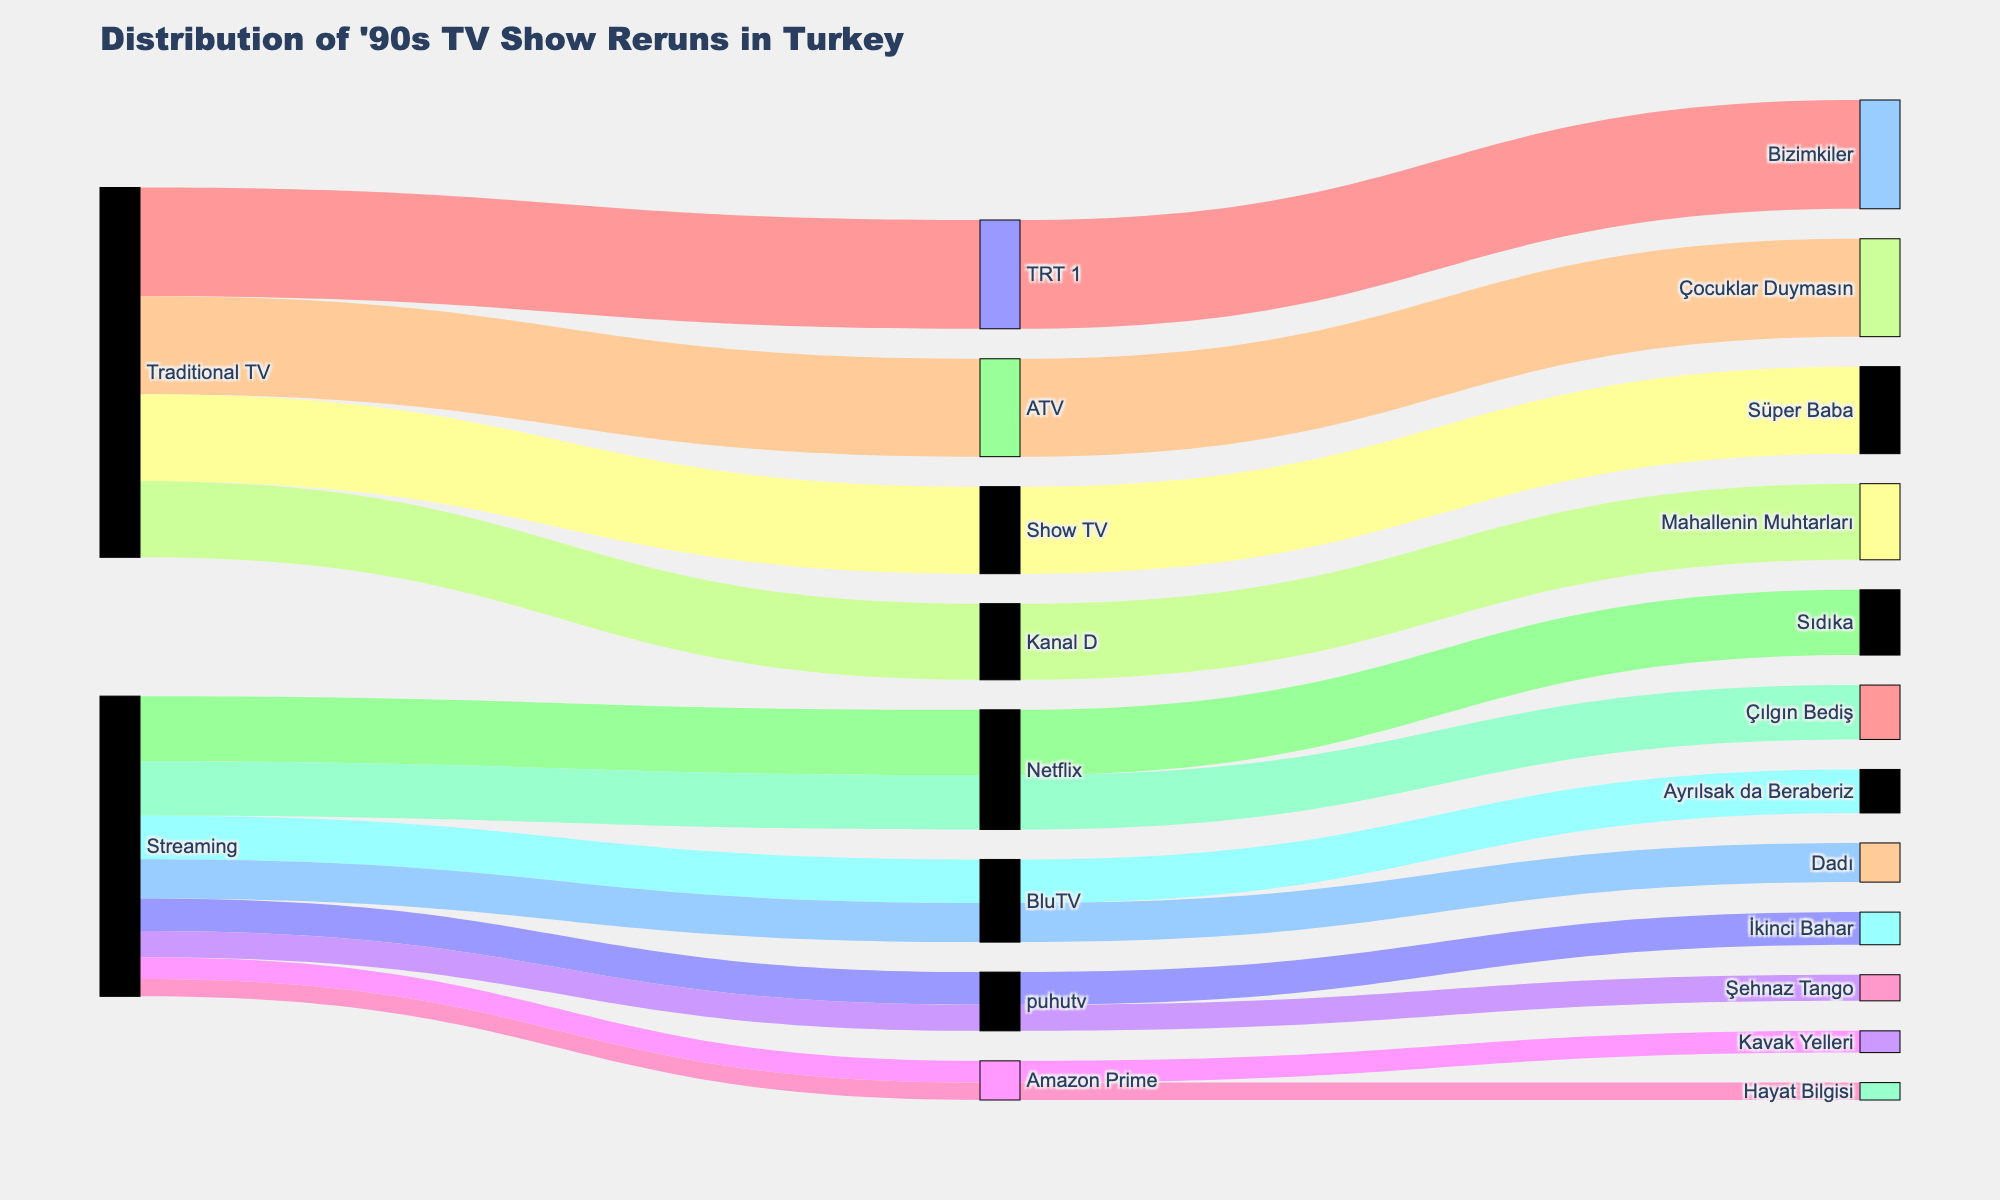What is the title of the figure? The title of the figure usually appears at the top, indicating what the graph represents. Here, it is "Distribution of '90s TV Show Reruns in Turkey".
Answer: Distribution of '90s TV Show Reruns in Turkey How many traditional TV channels are represented in the Sankey diagram? We need to count the number of unique traditional TV channels shown in the figure. They are TRT 1, ATV, Show TV, and Kanal D.
Answer: 4 Which show has the highest number of viewers? By following the width of the flows connected to each show, the one with the widest flow represents the show with the highest viewers. "Bizimkiler" on TRT 1 has the widest flow.
Answer: Bizimkiler How many shows are on streaming platforms compared to traditional TV channels? Sum up the shows under the streaming platforms section and the traditional TV channels section. Streaming platforms have Netflix, BluTV, puhutv, and Amazon Prime with a total of 7 shows, while traditional TV channels have 4 shows.
Answer: 7 on streaming platforms, 4 on traditional TV channels Which streaming platform has the fewest number of viewers for a single show? Observe the flows connected to each streaming platform and identify the show with the smallest flow. Amazon Prime's "Hayat Bilgisi" has the fewest viewers.
Answer: Amazon Prime ("Hayat Bilgisi" with 80,000 viewers) What is the total number of viewers for shows on Netflix? Sum up the viewer counts of all Netflix shows in the diagram. Netflix has "Sıdıka" with 300,000 viewers and "Çılgın Bediş" with 250,000 viewers. So, 300,000 + 250,000.
Answer: 550,000 Compare the viewers of "Çocuklar Duymasın" and "Hayat Bilgisi". Which show has more viewers? Compare the numbers directly from the diagram. "Çocuklar Duymasın" has 450,000 viewers, and "Hayat Bilgisi" has 80,000 viewers. Hence, "Çocuklar Duymasın" has more viewers.
Answer: Çocuklar Duymasın What is the combined viewership of all shows aired on puhutv? Add the viewers of "İkinci Bahar" and "Şehnaz Tango". "İkinci Bahar" has 150,000 viewers and "Şehnaz Tango" has 120,000 viewers. So, 150,000 + 120,000.
Answer: 270,000 Which traditional TV channel has the show with the smallest number of viewers? By comparing the flows connected to each traditional TV channel, "Mahallenin Muhtarları" on Kanal D has the least number of viewers with 350,000 viewers.
Answer: Kanal D How does the viewer count of "Süper Baba" compare to "Sıdıka"? Look at the viewer counts from the diagram. "Süper Baba" has 400,000 viewers on Show TV while "Sıdıka" has 300,000 viewers on Netflix. "Süper Baba" has more viewers.
Answer: Süper Baba 